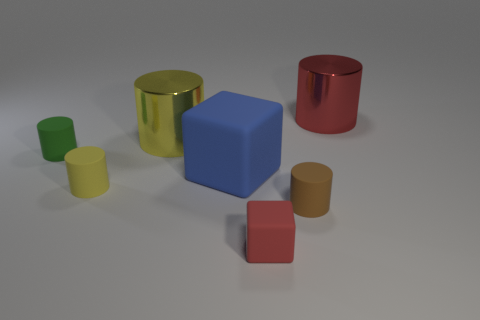The matte object that is both in front of the blue matte thing and behind the small brown matte cylinder has what shape?
Your answer should be very brief. Cylinder. Do the large red thing and the tiny yellow rubber object have the same shape?
Your response must be concise. Yes. What is the size of the cylinder that is both to the right of the large yellow cylinder and in front of the green matte cylinder?
Your answer should be very brief. Small. What number of things are either metallic cylinders that are left of the large red metal cylinder or tiny brown rubber cylinders?
Keep it short and to the point. 2. What shape is the large red thing that is the same material as the large yellow thing?
Offer a very short reply. Cylinder. What is the shape of the tiny brown thing?
Your answer should be compact. Cylinder. What is the color of the cylinder that is both in front of the large yellow cylinder and to the right of the red cube?
Your response must be concise. Brown. What shape is the red rubber thing that is the same size as the brown rubber thing?
Your answer should be very brief. Cube. Are there any other objects that have the same shape as the big red metal object?
Ensure brevity in your answer.  Yes. Are the large blue object and the cylinder that is in front of the tiny yellow object made of the same material?
Keep it short and to the point. Yes. 